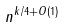<formula> <loc_0><loc_0><loc_500><loc_500>n ^ { k / 4 + O ( 1 ) }</formula> 